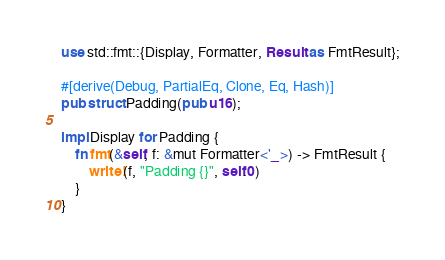Convert code to text. <code><loc_0><loc_0><loc_500><loc_500><_Rust_>use std::fmt::{Display, Formatter, Result as FmtResult};

#[derive(Debug, PartialEq, Clone, Eq, Hash)]
pub struct Padding(pub u16);

impl Display for Padding {
    fn fmt(&self, f: &mut Formatter<'_>) -> FmtResult {
        write!(f, "Padding {}", self.0)
    }
}
</code> 